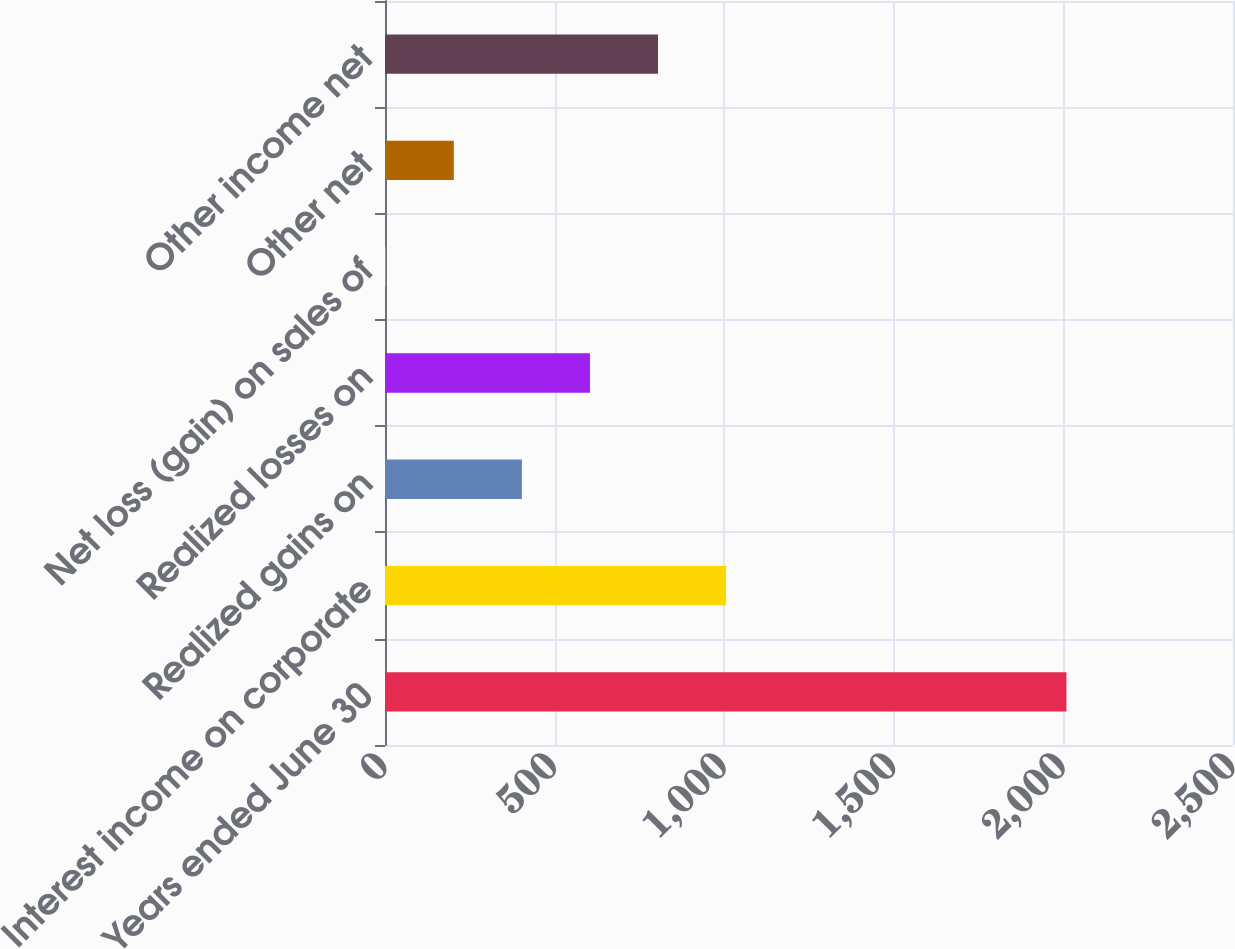<chart> <loc_0><loc_0><loc_500><loc_500><bar_chart><fcel>Years ended June 30<fcel>Interest income on corporate<fcel>Realized gains on<fcel>Realized losses on<fcel>Net loss (gain) on sales of<fcel>Other net<fcel>Other income net<nl><fcel>2009<fcel>1005.6<fcel>403.56<fcel>604.24<fcel>2.2<fcel>202.88<fcel>804.92<nl></chart> 